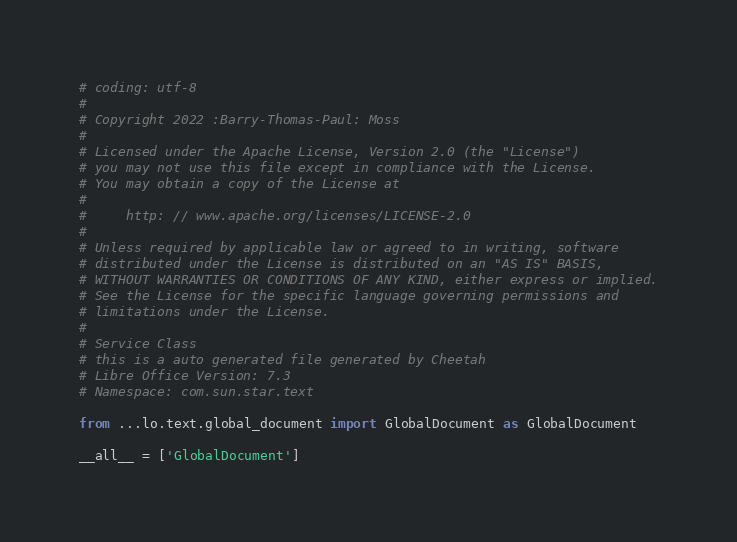Convert code to text. <code><loc_0><loc_0><loc_500><loc_500><_Python_># coding: utf-8
#
# Copyright 2022 :Barry-Thomas-Paul: Moss
#
# Licensed under the Apache License, Version 2.0 (the "License")
# you may not use this file except in compliance with the License.
# You may obtain a copy of the License at
#
#     http: // www.apache.org/licenses/LICENSE-2.0
#
# Unless required by applicable law or agreed to in writing, software
# distributed under the License is distributed on an "AS IS" BASIS,
# WITHOUT WARRANTIES OR CONDITIONS OF ANY KIND, either express or implied.
# See the License for the specific language governing permissions and
# limitations under the License.
#
# Service Class
# this is a auto generated file generated by Cheetah
# Libre Office Version: 7.3
# Namespace: com.sun.star.text

from ...lo.text.global_document import GlobalDocument as GlobalDocument

__all__ = ['GlobalDocument']

</code> 